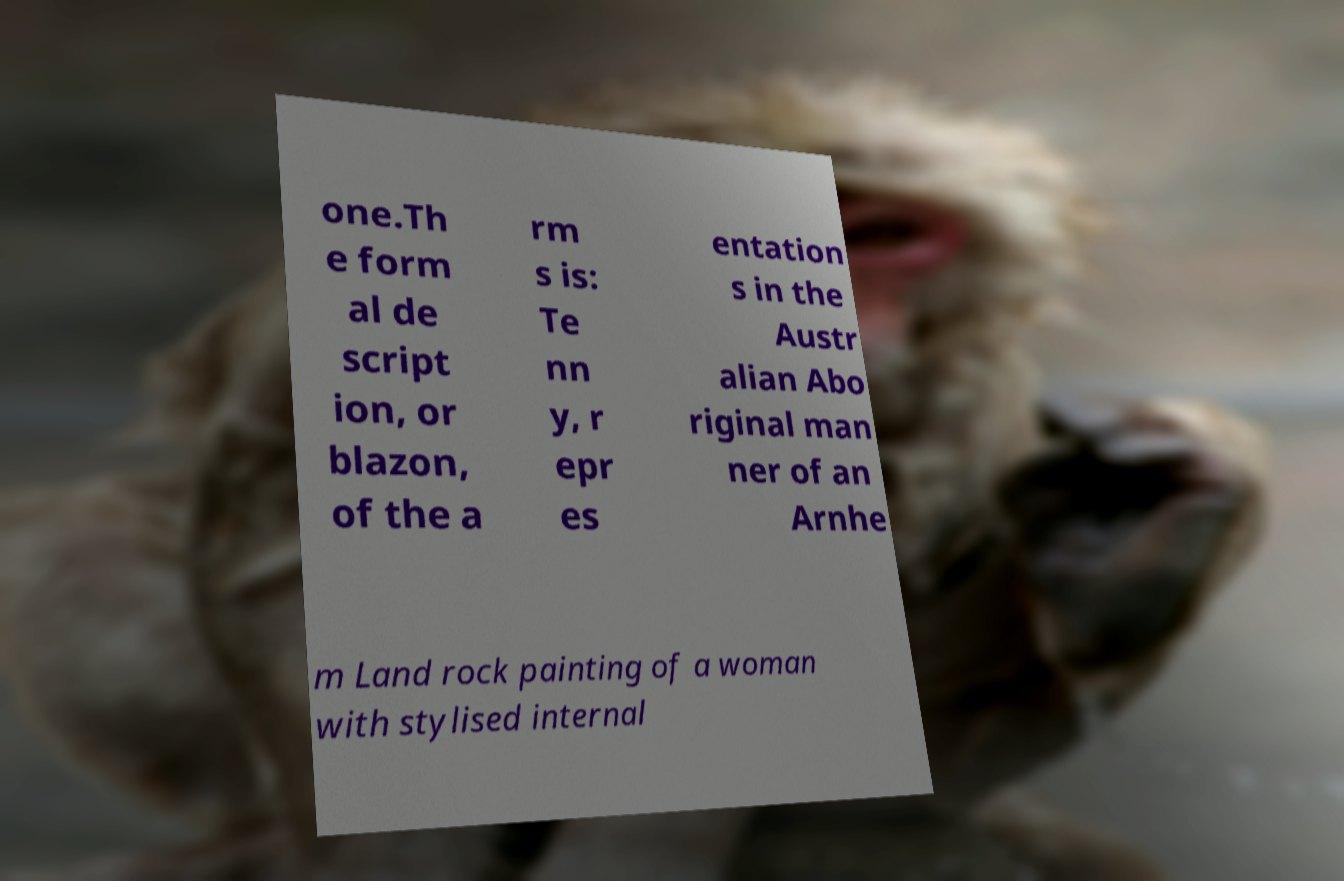Please read and relay the text visible in this image. What does it say? one.Th e form al de script ion, or blazon, of the a rm s is: Te nn y, r epr es entation s in the Austr alian Abo riginal man ner of an Arnhe m Land rock painting of a woman with stylised internal 